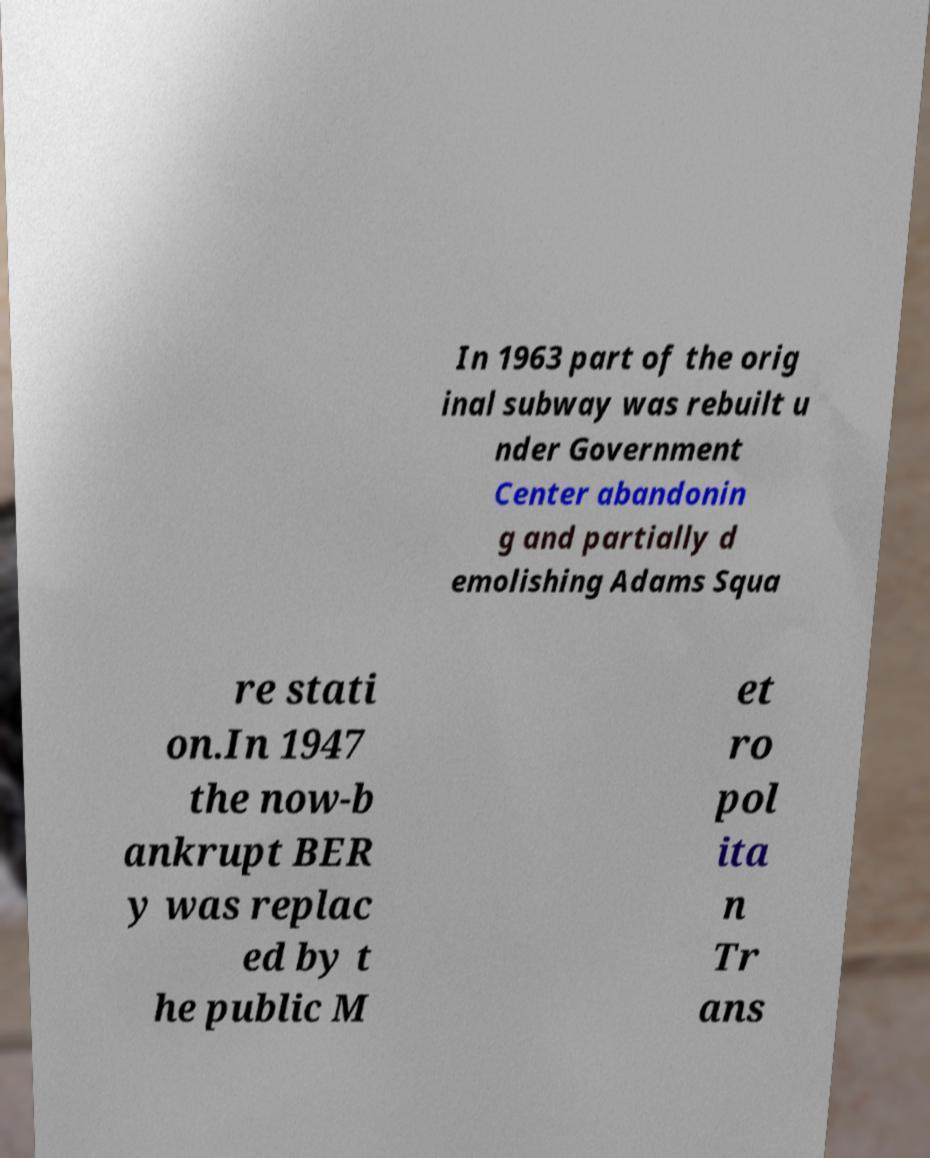I need the written content from this picture converted into text. Can you do that? In 1963 part of the orig inal subway was rebuilt u nder Government Center abandonin g and partially d emolishing Adams Squa re stati on.In 1947 the now-b ankrupt BER y was replac ed by t he public M et ro pol ita n Tr ans 